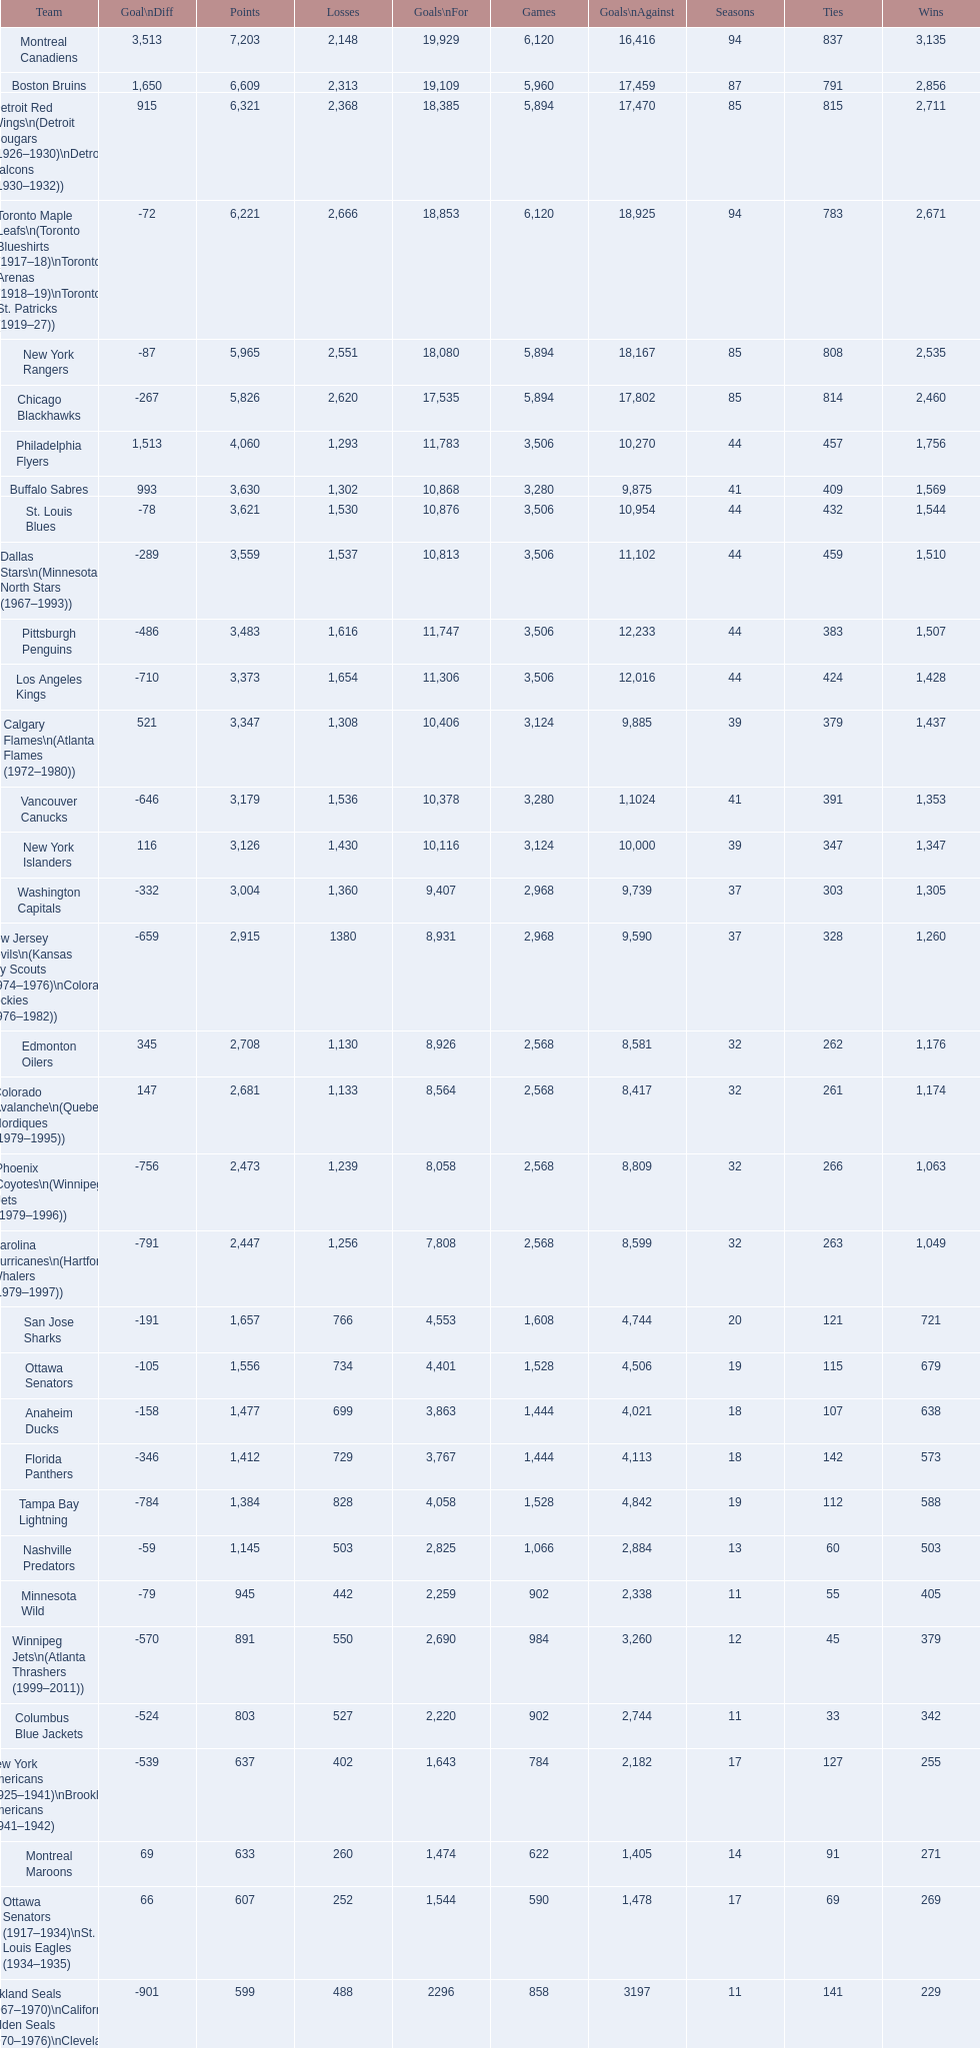Which team was last in terms of points up until this point? Montreal Wanderers. 